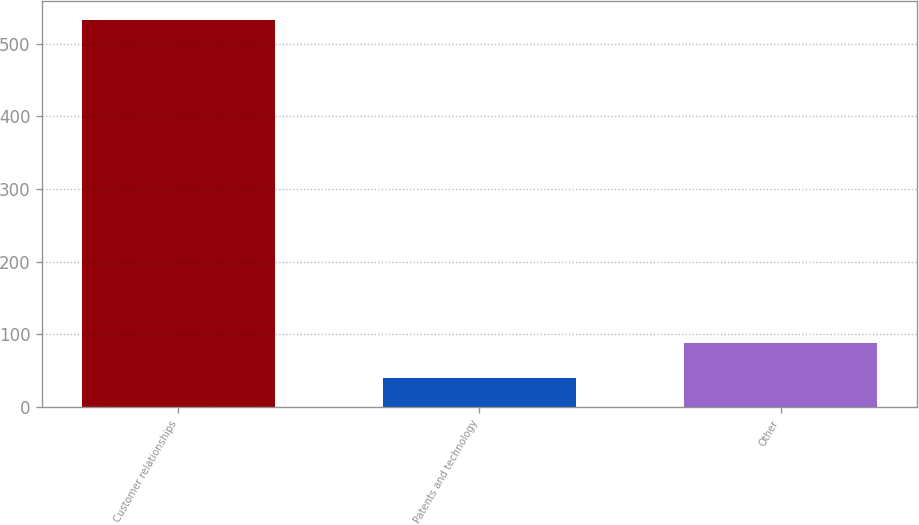Convert chart. <chart><loc_0><loc_0><loc_500><loc_500><bar_chart><fcel>Customer relationships<fcel>Patents and technology<fcel>Other<nl><fcel>531.9<fcel>39.2<fcel>88.47<nl></chart> 